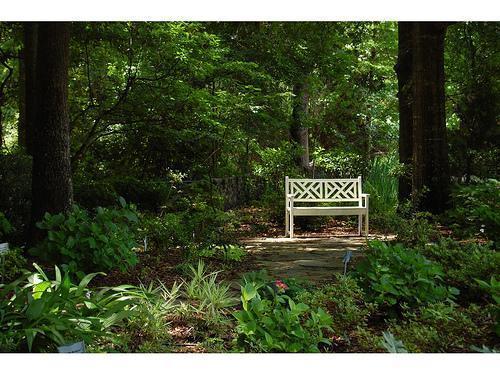How many benches are there?
Give a very brief answer. 1. 